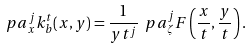<formula> <loc_0><loc_0><loc_500><loc_500>\ p a _ { x } ^ { j } k ^ { t } _ { b } ( x , y ) = \frac { 1 } { y t ^ { j } } \ p a _ { \zeta } ^ { j } F \left ( \frac { x } { t } , \frac { y } { t } \right ) .</formula> 